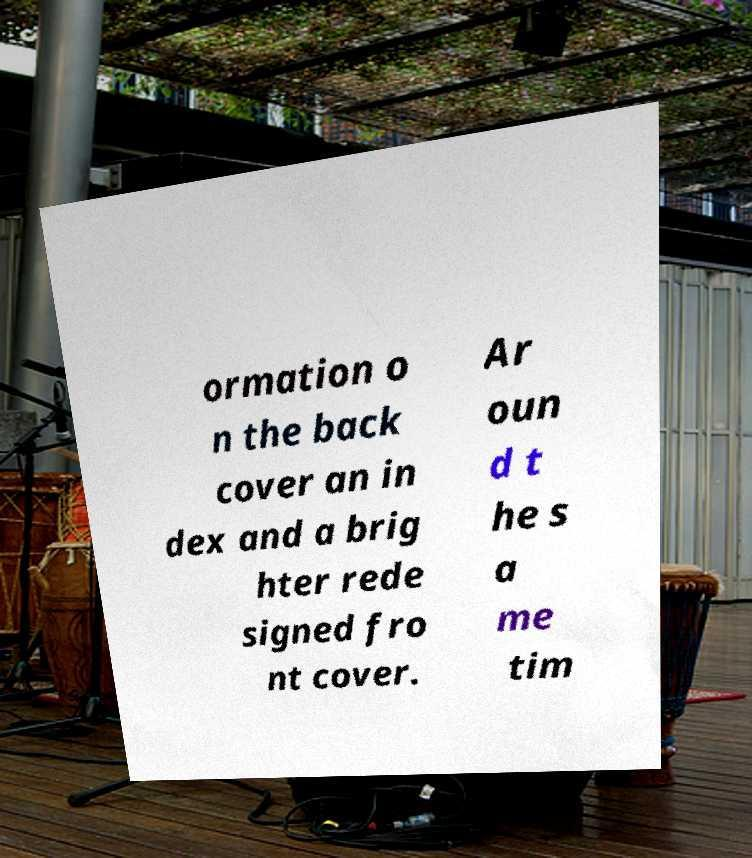Can you read and provide the text displayed in the image?This photo seems to have some interesting text. Can you extract and type it out for me? ormation o n the back cover an in dex and a brig hter rede signed fro nt cover. Ar oun d t he s a me tim 